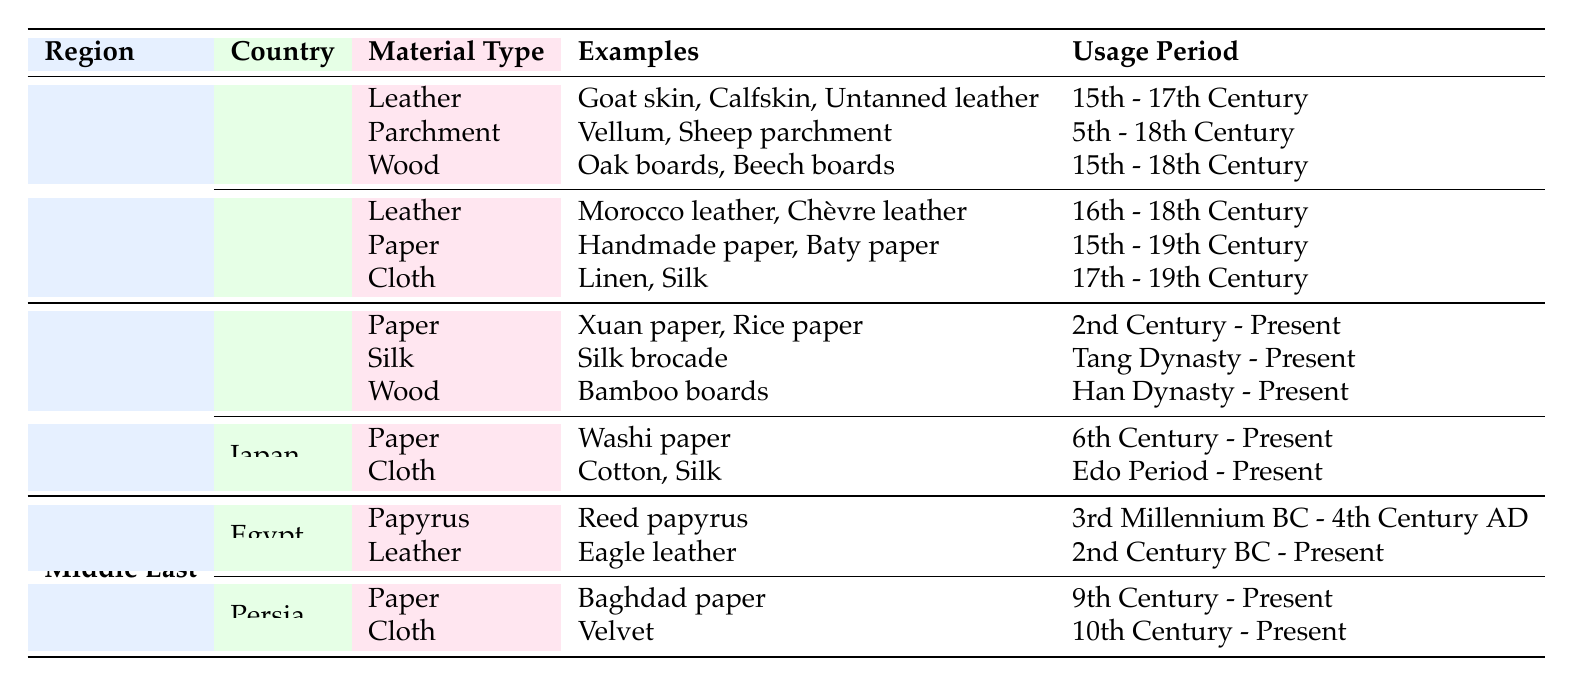What materials were used for bookbinding in Italy during the 15th to 17th centuries? In the table, under the category for Italy, the materials listed that were in use during the 15th to 17th centuries include Leather, Parchment, and Wood.
Answer: Leather, Parchment, Wood Did both China and Japan use paper as a bookbinding material? Yes, according to the table, both China and Japan have paper listed as a material type used in bookbinding. China used Xuan paper and Rice paper, while Japan used Washi paper.
Answer: Yes What is the usage period for leather materials used in bookbinding in France? The table indicates that leather materials in France were used from the 16th to the 18th century, as per the data in the relevant row under France.
Answer: 16th - 18th Century Which region used papyrus and what was its usage period? According to the table, the Middle East region, specifically Egypt, used papyrus from the 3rd Millennium BC to the 4th Century AD.
Answer: Middle East, 3rd Millennium BC - 4th Century AD How many different types of bookbinding materials were used in China? In the table, China has three types of materials listed: Paper, Silk, and Wood. Therefore, the count of different types is three.
Answer: 3 Were any types of cloth used in the bookbinding practices of Italy? No, based on the information in the table, Italy did not have any cloth listed as a bookbinding material. The materials listed were Leather, Parchment, and Wood.
Answer: No What examples of wood materials were used in bookbinding across all regions listed? The table lists Oak boards and Beech boards for Italy, Bamboo boards for China, and no wood type is mentioned for Japan, Egypt or Persia, making the examples across all regions Oak boards, Beech boards, and Bamboo boards.
Answer: Oak boards, Beech boards, Bamboo boards Which country in the Middle East used velvet as a bookbinding material, and during what period? According to the data in the table, Persia used Velvet as a bookbinding cloth starting from the 10th Century and still using it in the present.
Answer: Persia, 10th Century - Present What is the average usage period for bookbinding paper materials across all regions? To find the average, we can look at the listed periods: China's paper is from the 2nd Century to Present, Japan's Washi paper is from the 6th Century to Present, and Persia from the 9th Century to Present. However, these periods overlap. Calculating the range from the earliest (2nd Century) to the latest common point (Present) leads to overlapping counts, thus averaging is complex without clear numerical values.
Answer: Complex overlapping periods do not yield a simple average 